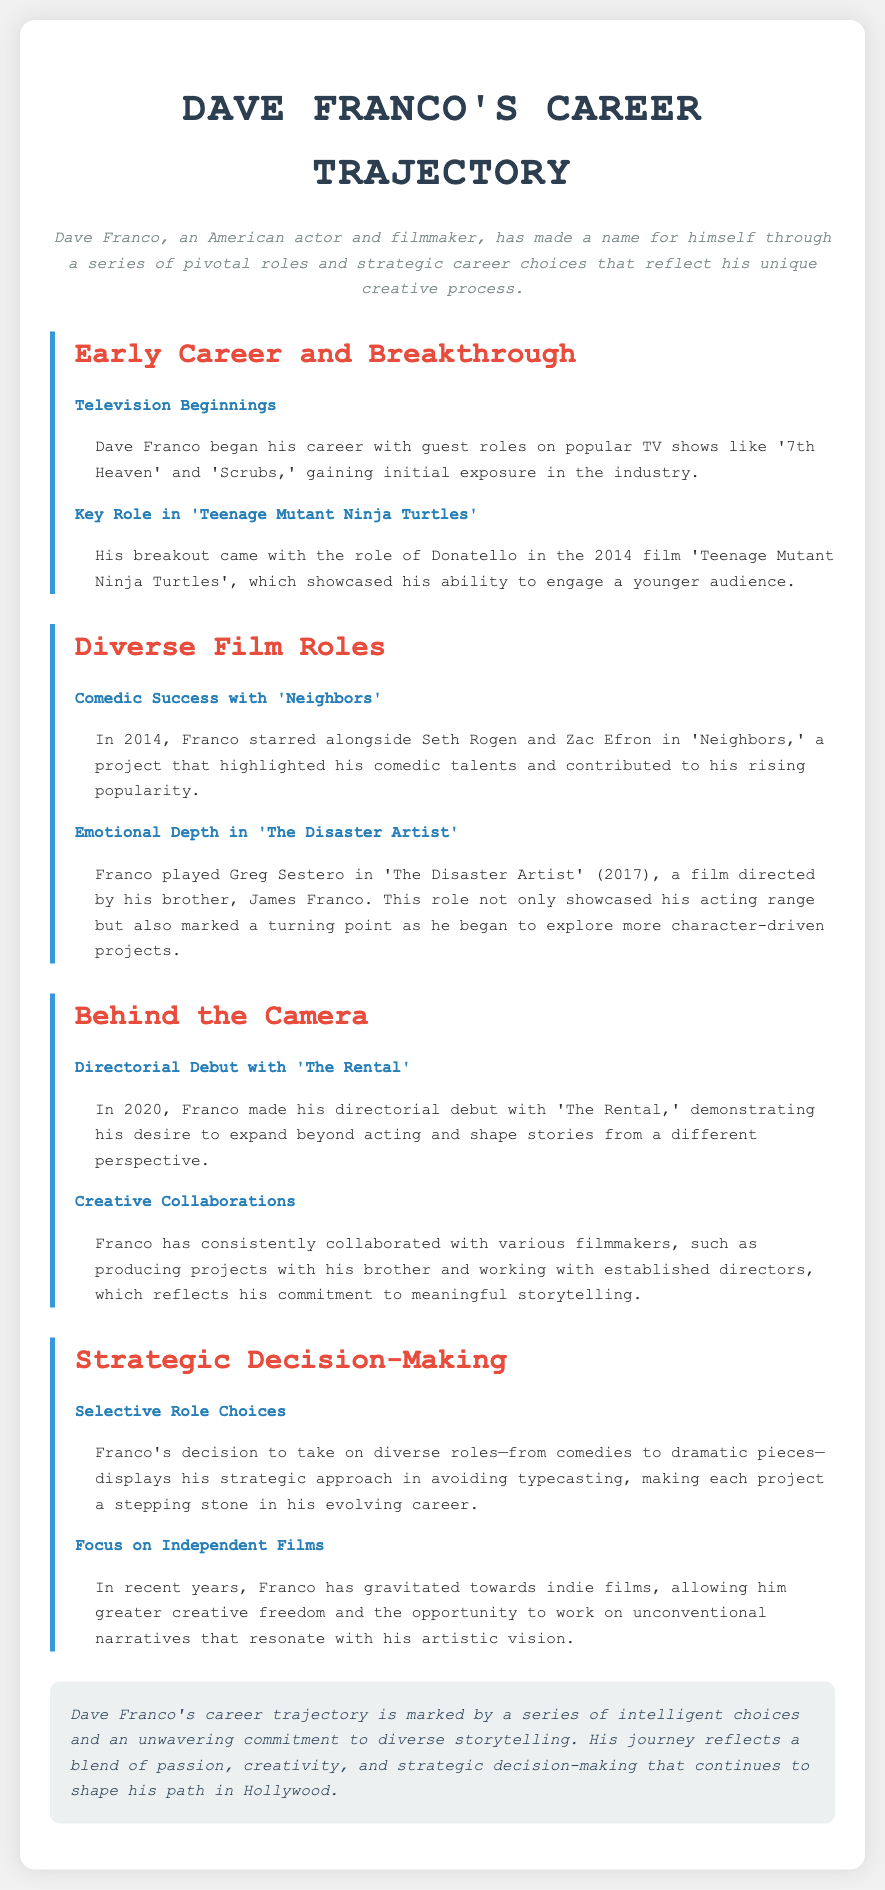What role did Dave Franco play in 'Teenage Mutant Ninja Turtles'? The document states that Franco's breakout came with the role of Donatello in the film.
Answer: Donatello What year did Dave Franco make his directorial debut? According to the document, he made his directorial debut in 2020 with 'The Rental.'
Answer: 2020 Which film showcased Dave Franco's comedic talents alongside Seth Rogen? The document highlights that Franco starred in 'Neighbors' with Seth Rogen in 2014.
Answer: Neighbors What type of films has Franco gravitated towards in recent years? The text indicates that he has gravitated towards indie films for greater creative freedom.
Answer: Indie films What was a turning point for Franco's acting range mentioned in the document? The document notes that playing Greg Sestero in 'The Disaster Artist' marked a turning point in his exploration of character-driven projects.
Answer: The Disaster Artist How did Franco's early roles influence his career? The document describes his early roles on TV as providing initial exposure in the industry.
Answer: Initial exposure What does Franco's selective role choices demonstrate about his career approach? The document explains that his selective role choices display a strategic approach to avoid typecasting.
Answer: Strategic approach Who directed 'The Disaster Artist'? As noted in the document, the film was directed by his brother, James Franco.
Answer: James Franco 